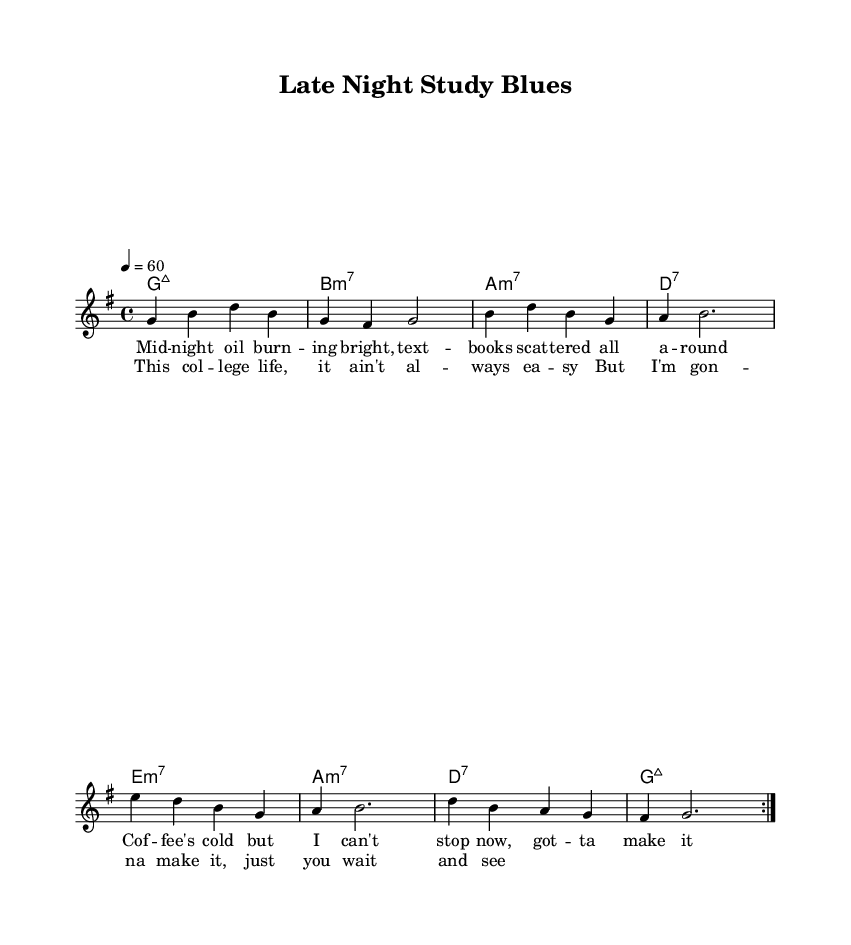What is the key signature of this music? The key signature is G major, which has one sharp (F#). This is determined by looking at the beginning of the staff where the sharps are indicated.
Answer: G major What is the time signature of this music? The time signature is 4/4, which can be identified by the numbers at the beginning of the score. This means there are four beats per measure.
Answer: 4/4 What is the tempo marking for this piece? The tempo marking is quarter note equals 60, indicated in the tempo directive at the beginning of the score. This specifies the speed of the piece.
Answer: 60 How many measures are in the verse? There are eight measures in the verse. This can be seen by counting the measure bars in the melody and the lyric lines.
Answer: 8 What is the chord progression for the chorus? The chord progression for the chorus is G major, B minor, A minor, D seventh, E minor, A minor, D seventh, G major. This can be inferred by analyzing the harmony notations corresponding to the lyrics.
Answer: G, Bm, Am, D7, Em, Am, D7, G What is the mood conveyed in this R&B ballad? The mood conveyed is a sense of determination and struggle, highlighted by lyrics that speak to the challenges of college life, which is a common theme in R&B music. This can be inferred by reading the lyric content and context provided.
Answer: Determination What is the melodic range of the piece? The melodic range spans from the note G to D, which can be determined by observing the lowest and highest notes in the melody staff.
Answer: G to D 